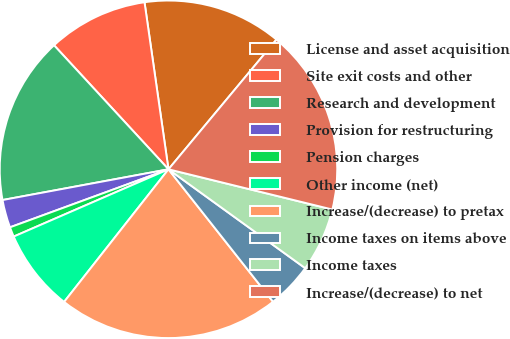Convert chart to OTSL. <chart><loc_0><loc_0><loc_500><loc_500><pie_chart><fcel>License and asset acquisition<fcel>Site exit costs and other<fcel>Research and development<fcel>Provision for restructuring<fcel>Pension charges<fcel>Other income (net)<fcel>Increase/(decrease) to pretax<fcel>Income taxes on items above<fcel>Income taxes<fcel>Increase/(decrease) to net<nl><fcel>13.31%<fcel>9.59%<fcel>16.05%<fcel>2.67%<fcel>0.94%<fcel>7.86%<fcel>21.24%<fcel>4.4%<fcel>6.13%<fcel>17.78%<nl></chart> 